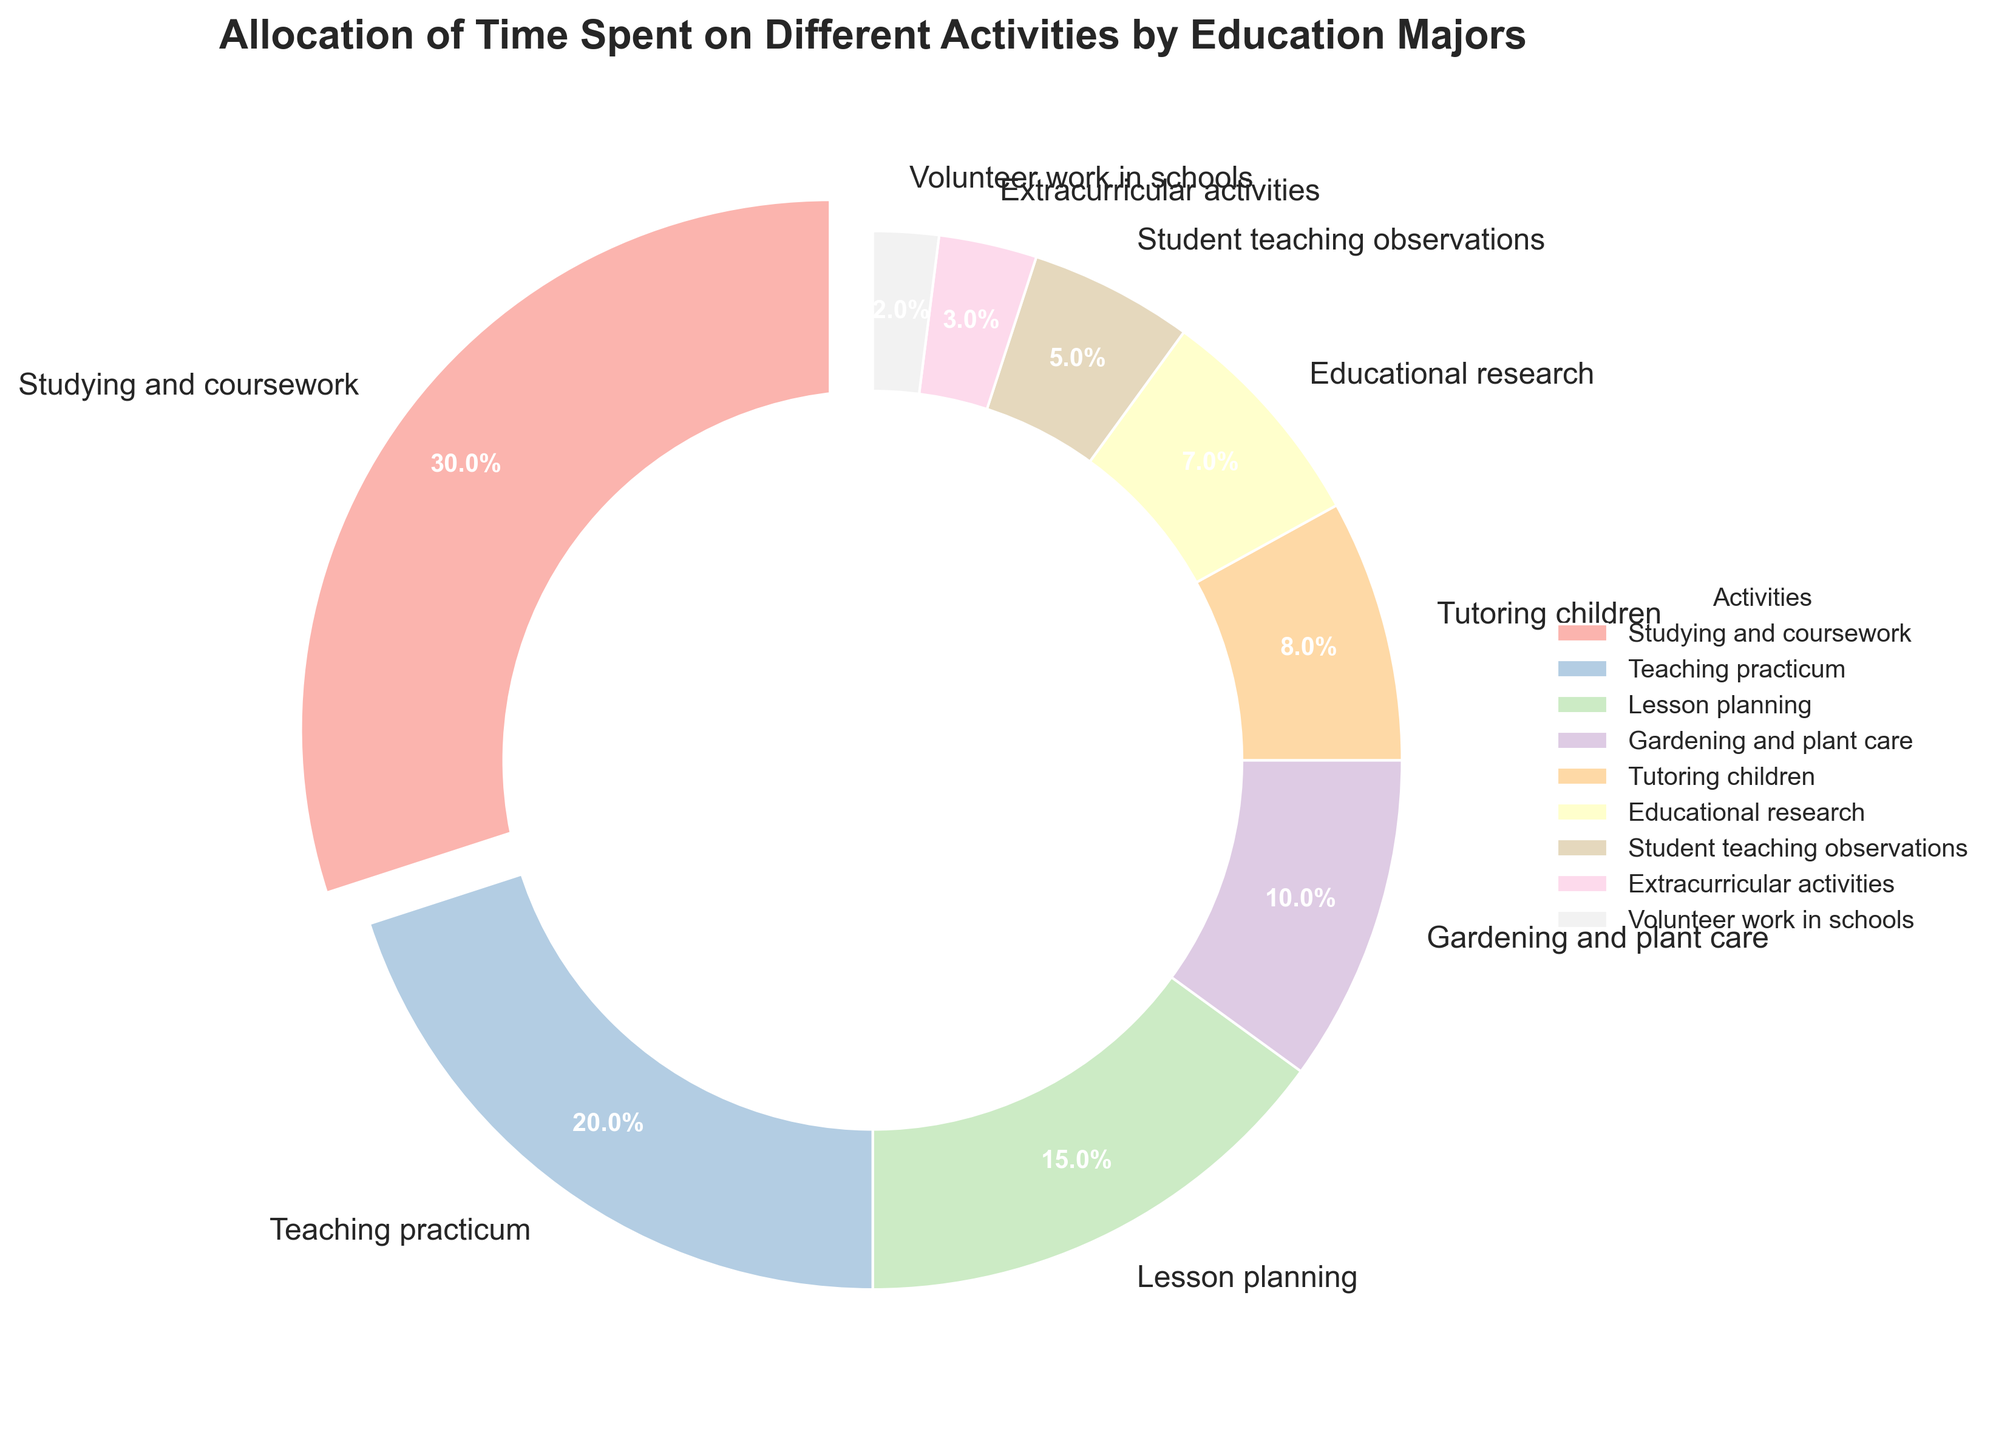What activity do education majors spend the most time on? The activity with the highest percentage wedge in the pie chart is "Studying and coursework" at 30%, which is visually emphasized with a slight explosion effect.
Answer: Studying and coursework Which activities together make up more than 50% of the time allocation? Summing "Studying and coursework" (30%) and "Teaching practicum" (20%) results in 50%, which means adding any of the next activity will surpass 50%. Thus, "Studying and coursework" (30%) and "Teaching practicum" (20%) together make up 50%.
Answer: Studying and coursework and Teaching practicum Which activity is represented by the smallest wedge in the pie chart? The smallest wedge in the pie chart is labeled "Volunteer work in schools," which has a percentage of 2%.
Answer: Volunteer work in schools By how much is the time spent on lesson planning greater than the time spent on tutoring children? The percentages for lesson planning and tutoring children are 15% and 8%, respectively. The difference between them is calculated as 15% - 8% = 7%.
Answer: 7% What is the total percentage of time spent on activities not directly related to coursework or practicum (i.e., excluding studying, coursework, and teaching practicum)? Excluding "Studying and coursework" (30%) and "Teaching practicum" (20%), sum the remaining percentages: 15% + 10% + 8% + 7% + 5% + 3% + 2% = 50%.
Answer: 50% Which activity has a wedge located immediately counterclockwise to Educational research? In the pie chart, moving counterclockwise from "Educational research" (7%), the next activity is "Tutoring children" (8%).
Answer: Tutoring children What is the average percentage of time spent on extracurricular activities and volunteer work in schools? The percentages for extracurricular activities and volunteer work in schools are 3% and 2%, respectively. The average is calculated as (3% + 2%) / 2 = 2.5%.
Answer: 2.5% Which activity has a larger wedge: Gardening and plant care or Student teaching observations? The percentage for "Gardening and plant care" is 10%, and for "Student teaching observations" is 5%. Therefore, "Gardening and plant care" has a larger wedge.
Answer: Gardening and plant care If the activities "Studying and coursework" and "Teaching practicum" were combined into one category, what would be their combined percentage? Add the percentages of "Studying and coursework" (30%) and "Teaching practicum" (20%) to get a combined percentage of 30% + 20% = 50%.
Answer: 50% 